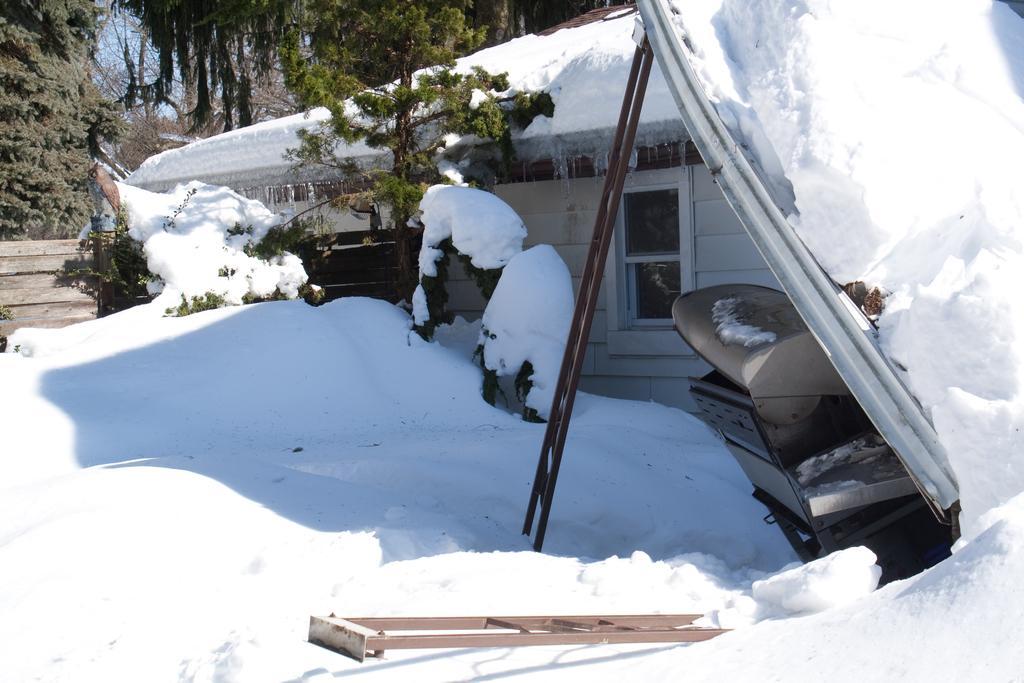Could you give a brief overview of what you see in this image? In the given picture there is a house which is fully covered with snow and we can observe some trees here. It was fully covered with snow all over the land. In the background there is a tree. 